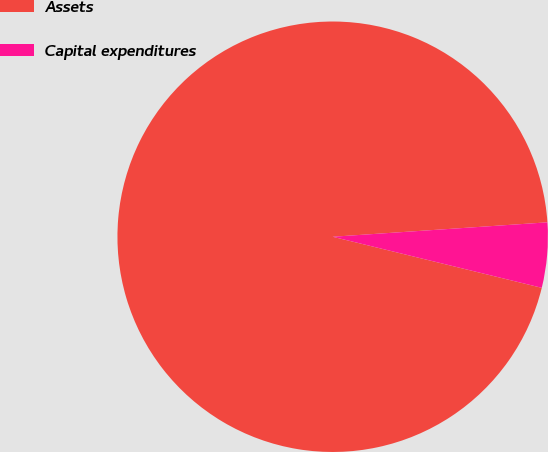<chart> <loc_0><loc_0><loc_500><loc_500><pie_chart><fcel>Assets<fcel>Capital expenditures<nl><fcel>95.12%<fcel>4.88%<nl></chart> 